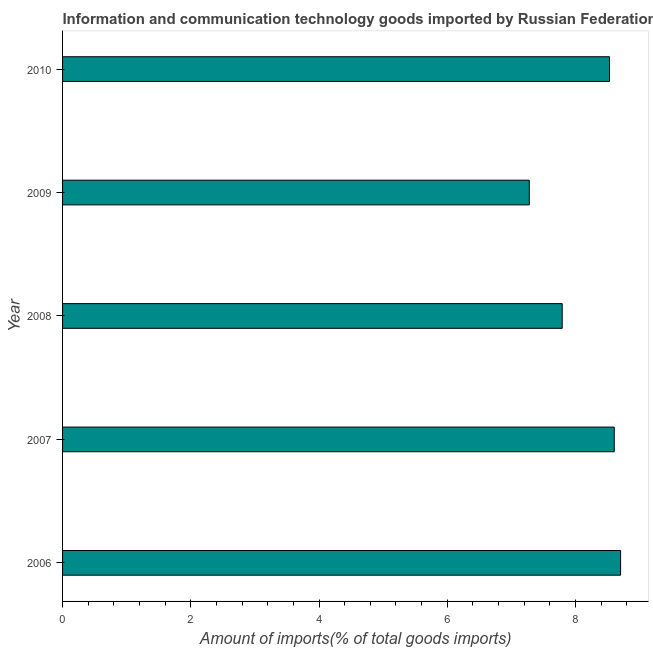What is the title of the graph?
Your answer should be compact. Information and communication technology goods imported by Russian Federation. What is the label or title of the X-axis?
Make the answer very short. Amount of imports(% of total goods imports). What is the amount of ict goods imports in 2008?
Provide a short and direct response. 7.79. Across all years, what is the maximum amount of ict goods imports?
Your response must be concise. 8.7. Across all years, what is the minimum amount of ict goods imports?
Provide a succinct answer. 7.28. In which year was the amount of ict goods imports minimum?
Make the answer very short. 2009. What is the sum of the amount of ict goods imports?
Your response must be concise. 40.91. What is the difference between the amount of ict goods imports in 2007 and 2008?
Offer a very short reply. 0.81. What is the average amount of ict goods imports per year?
Your answer should be compact. 8.18. What is the median amount of ict goods imports?
Make the answer very short. 8.53. Do a majority of the years between 2006 and 2007 (inclusive) have amount of ict goods imports greater than 1.6 %?
Your response must be concise. Yes. What is the ratio of the amount of ict goods imports in 2007 to that in 2008?
Make the answer very short. 1.1. Is the amount of ict goods imports in 2006 less than that in 2010?
Offer a very short reply. No. What is the difference between the highest and the second highest amount of ict goods imports?
Make the answer very short. 0.1. Is the sum of the amount of ict goods imports in 2007 and 2009 greater than the maximum amount of ict goods imports across all years?
Keep it short and to the point. Yes. What is the difference between the highest and the lowest amount of ict goods imports?
Your answer should be compact. 1.42. In how many years, is the amount of ict goods imports greater than the average amount of ict goods imports taken over all years?
Your response must be concise. 3. How many bars are there?
Provide a succinct answer. 5. Are all the bars in the graph horizontal?
Your response must be concise. Yes. Are the values on the major ticks of X-axis written in scientific E-notation?
Your response must be concise. No. What is the Amount of imports(% of total goods imports) in 2006?
Your answer should be compact. 8.7. What is the Amount of imports(% of total goods imports) of 2007?
Provide a short and direct response. 8.6. What is the Amount of imports(% of total goods imports) in 2008?
Offer a very short reply. 7.79. What is the Amount of imports(% of total goods imports) in 2009?
Offer a terse response. 7.28. What is the Amount of imports(% of total goods imports) of 2010?
Provide a short and direct response. 8.53. What is the difference between the Amount of imports(% of total goods imports) in 2006 and 2007?
Give a very brief answer. 0.1. What is the difference between the Amount of imports(% of total goods imports) in 2006 and 2008?
Your response must be concise. 0.91. What is the difference between the Amount of imports(% of total goods imports) in 2006 and 2009?
Provide a succinct answer. 1.42. What is the difference between the Amount of imports(% of total goods imports) in 2006 and 2010?
Offer a very short reply. 0.17. What is the difference between the Amount of imports(% of total goods imports) in 2007 and 2008?
Offer a terse response. 0.81. What is the difference between the Amount of imports(% of total goods imports) in 2007 and 2009?
Offer a terse response. 1.32. What is the difference between the Amount of imports(% of total goods imports) in 2007 and 2010?
Give a very brief answer. 0.07. What is the difference between the Amount of imports(% of total goods imports) in 2008 and 2009?
Your response must be concise. 0.51. What is the difference between the Amount of imports(% of total goods imports) in 2008 and 2010?
Offer a terse response. -0.74. What is the difference between the Amount of imports(% of total goods imports) in 2009 and 2010?
Your response must be concise. -1.25. What is the ratio of the Amount of imports(% of total goods imports) in 2006 to that in 2007?
Offer a terse response. 1.01. What is the ratio of the Amount of imports(% of total goods imports) in 2006 to that in 2008?
Offer a very short reply. 1.12. What is the ratio of the Amount of imports(% of total goods imports) in 2006 to that in 2009?
Give a very brief answer. 1.2. What is the ratio of the Amount of imports(% of total goods imports) in 2007 to that in 2008?
Make the answer very short. 1.1. What is the ratio of the Amount of imports(% of total goods imports) in 2007 to that in 2009?
Give a very brief answer. 1.18. What is the ratio of the Amount of imports(% of total goods imports) in 2008 to that in 2009?
Keep it short and to the point. 1.07. What is the ratio of the Amount of imports(% of total goods imports) in 2008 to that in 2010?
Keep it short and to the point. 0.91. What is the ratio of the Amount of imports(% of total goods imports) in 2009 to that in 2010?
Provide a short and direct response. 0.85. 